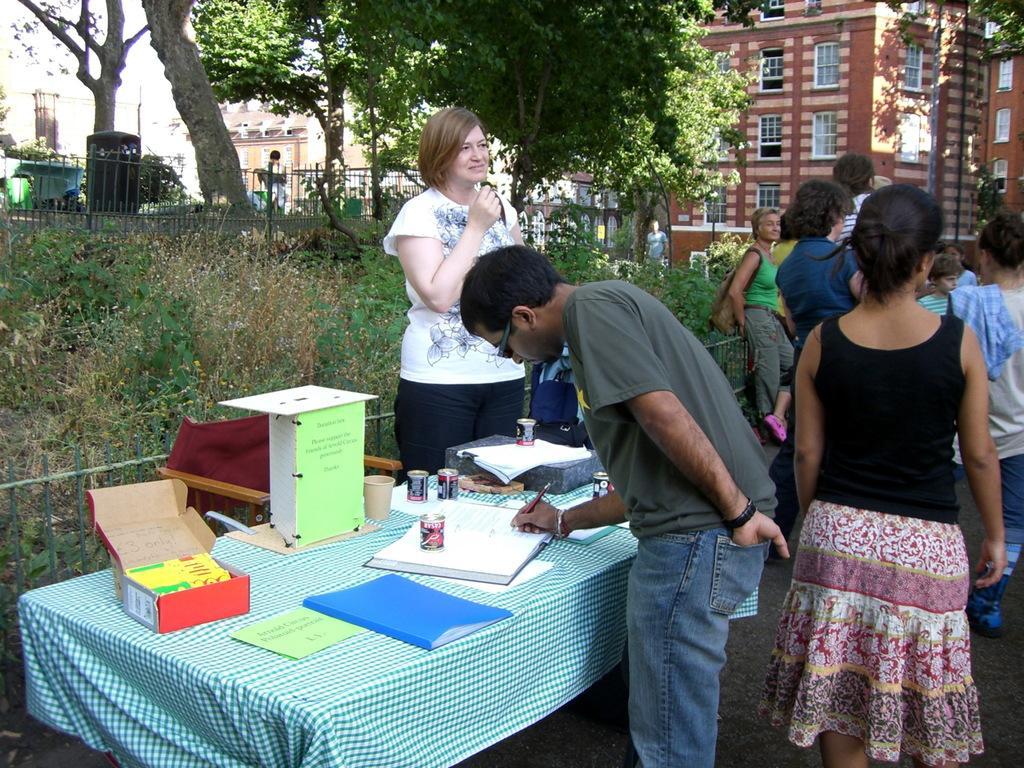In one or two sentences, can you explain what this image depicts? It is some Expo there is a table on the table there are some books and bottles in front of the table a woman is standing to her right side there are also some other people who are standing in the opposite side a man wearing grey color shirt is writing something on book ,in the background there are small plants ,trees, big buildings and sky. 